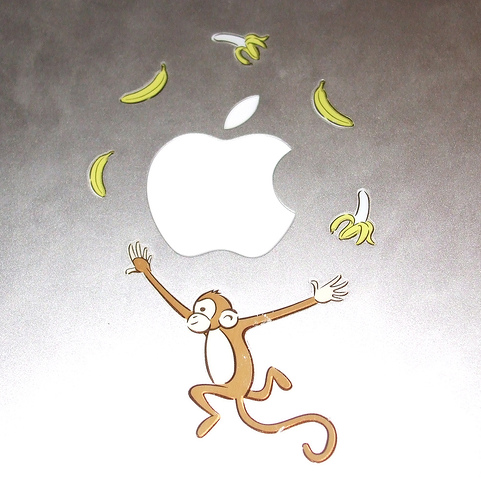<image>
Is the monkey under the apple? Yes. The monkey is positioned underneath the apple, with the apple above it in the vertical space. 